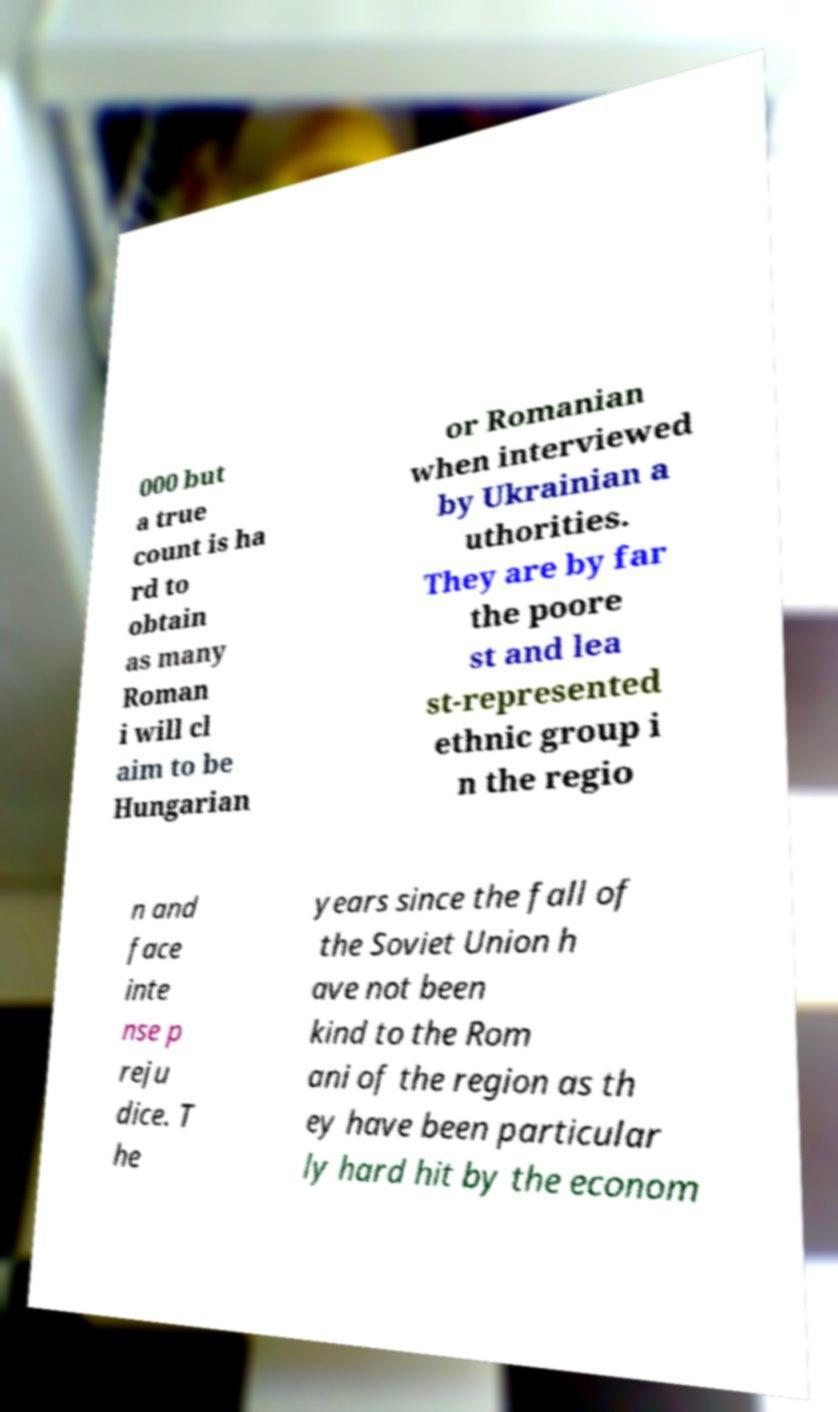Can you accurately transcribe the text from the provided image for me? 000 but a true count is ha rd to obtain as many Roman i will cl aim to be Hungarian or Romanian when interviewed by Ukrainian a uthorities. They are by far the poore st and lea st-represented ethnic group i n the regio n and face inte nse p reju dice. T he years since the fall of the Soviet Union h ave not been kind to the Rom ani of the region as th ey have been particular ly hard hit by the econom 